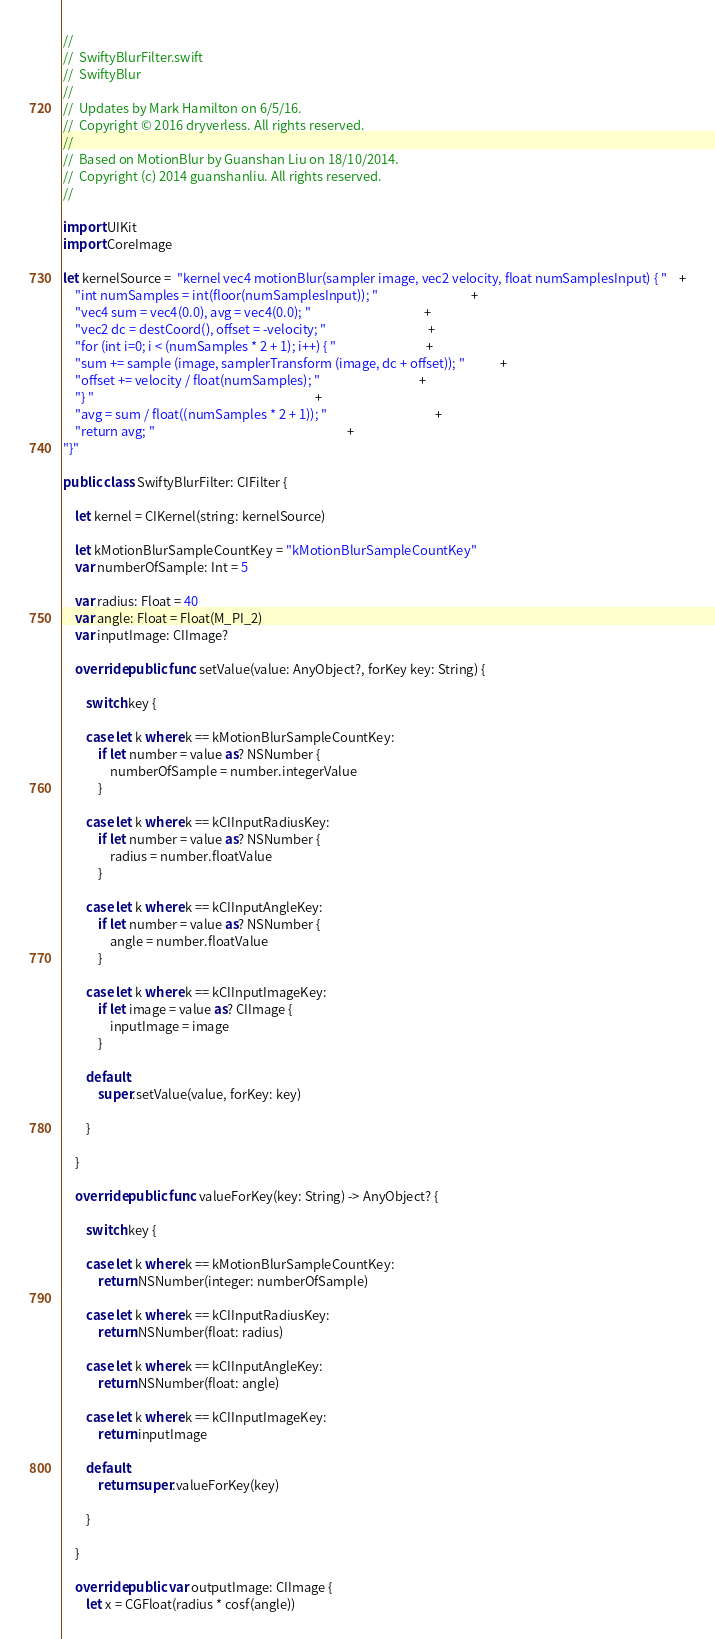Convert code to text. <code><loc_0><loc_0><loc_500><loc_500><_Swift_>//
//  SwiftyBlurFilter.swift
//  SwiftyBlur
//
//  Updates by Mark Hamilton on 6/5/16.
//  Copyright © 2016 dryverless. All rights reserved.
//
//  Based on MotionBlur by Guanshan Liu on 18/10/2014.
//  Copyright (c) 2014 guanshanliu. All rights reserved.
//

import UIKit
import CoreImage

let kernelSource =  "kernel vec4 motionBlur(sampler image, vec2 velocity, float numSamplesInput) { "    +
    "int numSamples = int(floor(numSamplesInput)); "                                +
    "vec4 sum = vec4(0.0), avg = vec4(0.0); "                                       +
    "vec2 dc = destCoord(), offset = -velocity; "                                   +
    "for (int i=0; i < (numSamples * 2 + 1); i++) { "                               +
    "sum += sample (image, samplerTransform (image, dc + offset)); "            +
    "offset += velocity / float(numSamples); "                                  +
    "} "                                                                            +
    "avg = sum / float((numSamples * 2 + 1)); "                                     +
    "return avg; "                                                                  +
"}"

public class SwiftyBlurFilter: CIFilter {
    
    let kernel = CIKernel(string: kernelSource)
    
    let kMotionBlurSampleCountKey = "kMotionBlurSampleCountKey"
    var numberOfSample: Int = 5
    
    var radius: Float = 40
    var angle: Float = Float(M_PI_2)
    var inputImage: CIImage?
    
    override public func setValue(value: AnyObject?, forKey key: String) {
        
        switch key {
            
        case let k where k == kMotionBlurSampleCountKey:
            if let number = value as? NSNumber {
                numberOfSample = number.integerValue
            }
            
        case let k where k == kCIInputRadiusKey:
            if let number = value as? NSNumber {
                radius = number.floatValue
            }
            
        case let k where k == kCIInputAngleKey:
            if let number = value as? NSNumber {
                angle = number.floatValue
            }
            
        case let k where k == kCIInputImageKey:
            if let image = value as? CIImage {
                inputImage = image
            }
            
        default:
            super.setValue(value, forKey: key)
            
        }
        
    }
    
    override public func valueForKey(key: String) -> AnyObject? {
        
        switch key {
            
        case let k where k == kMotionBlurSampleCountKey:
            return NSNumber(integer: numberOfSample)
            
        case let k where k == kCIInputRadiusKey:
            return NSNumber(float: radius)
            
        case let k where k == kCIInputAngleKey:
            return NSNumber(float: angle)
            
        case let k where k == kCIInputImageKey:
            return inputImage
            
        default:
            return super.valueForKey(key)
            
        }
        
    }
    
    override public var outputImage: CIImage {
        let x = CGFloat(radius * cosf(angle))</code> 